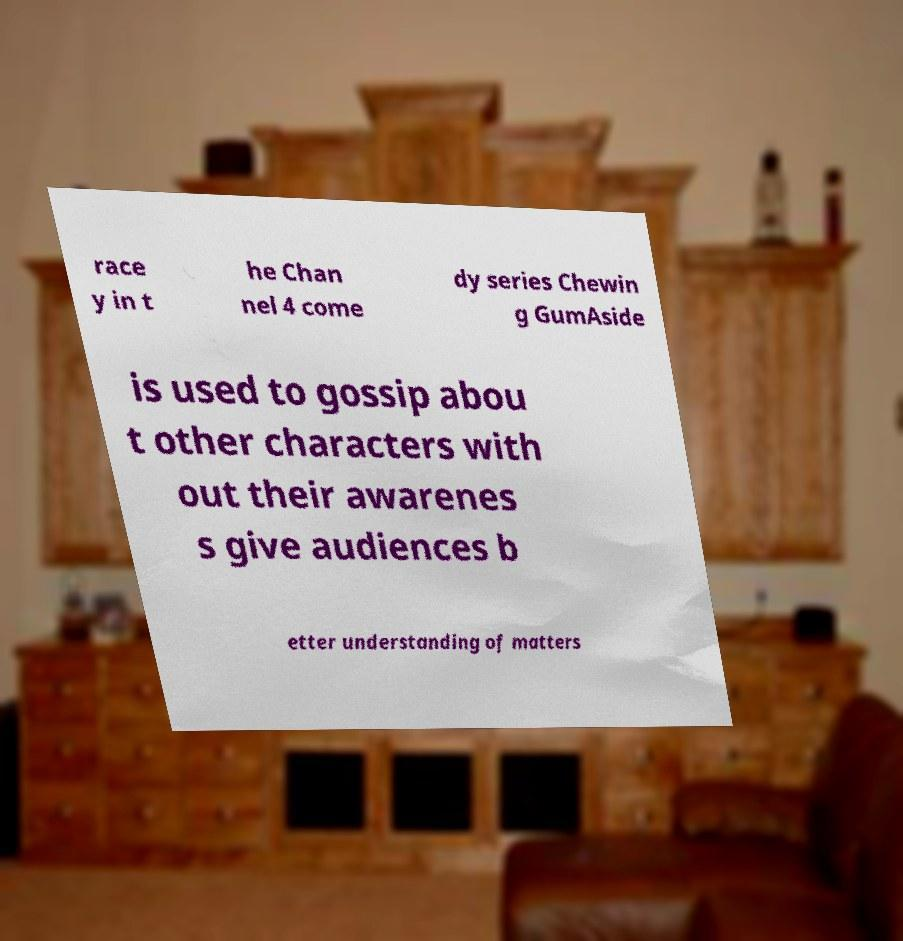What messages or text are displayed in this image? I need them in a readable, typed format. race y in t he Chan nel 4 come dy series Chewin g GumAside is used to gossip abou t other characters with out their awarenes s give audiences b etter understanding of matters 